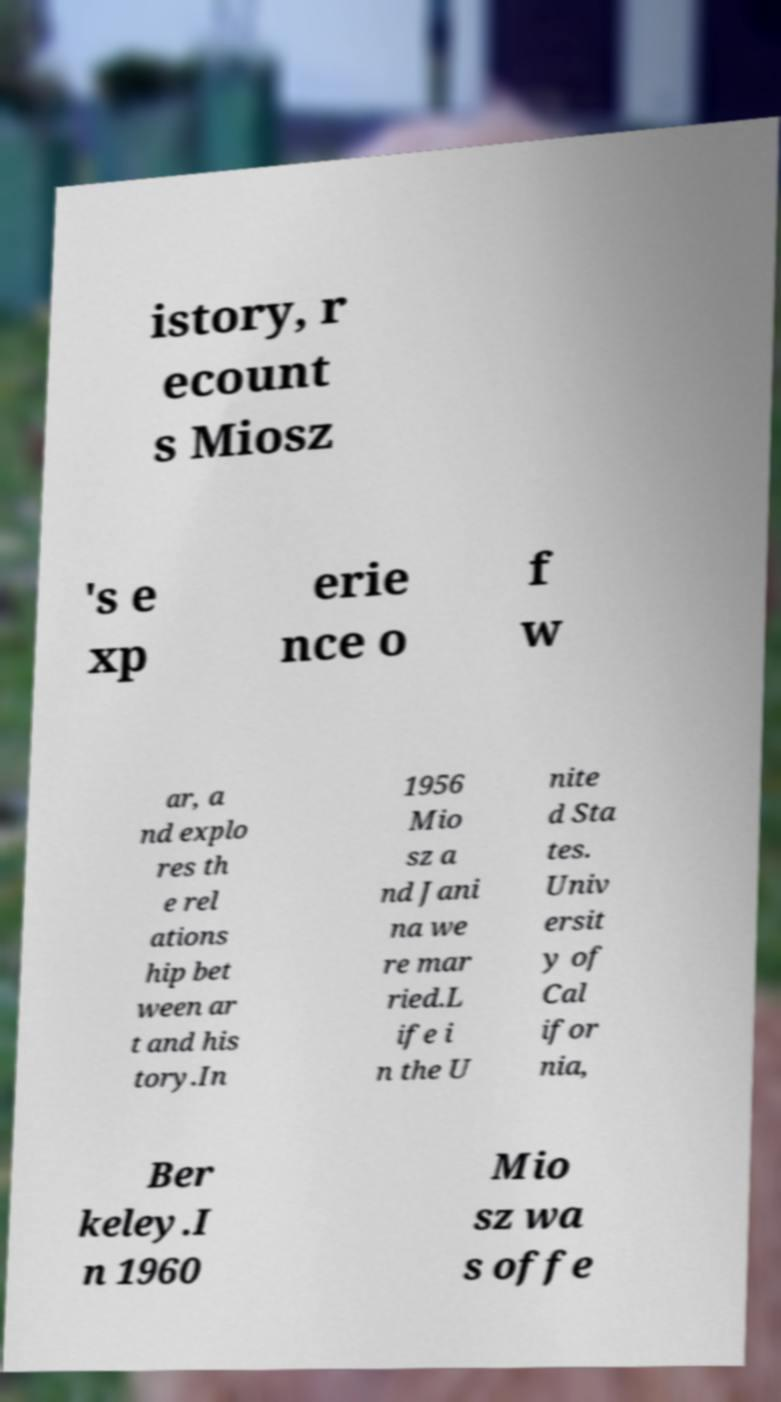What messages or text are displayed in this image? I need them in a readable, typed format. istory, r ecount s Miosz 's e xp erie nce o f w ar, a nd explo res th e rel ations hip bet ween ar t and his tory.In 1956 Mio sz a nd Jani na we re mar ried.L ife i n the U nite d Sta tes. Univ ersit y of Cal ifor nia, Ber keley.I n 1960 Mio sz wa s offe 